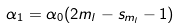Convert formula to latex. <formula><loc_0><loc_0><loc_500><loc_500>\alpha _ { 1 } = \alpha _ { 0 } ( 2 m _ { l } - s _ { m _ { l } } - 1 )</formula> 